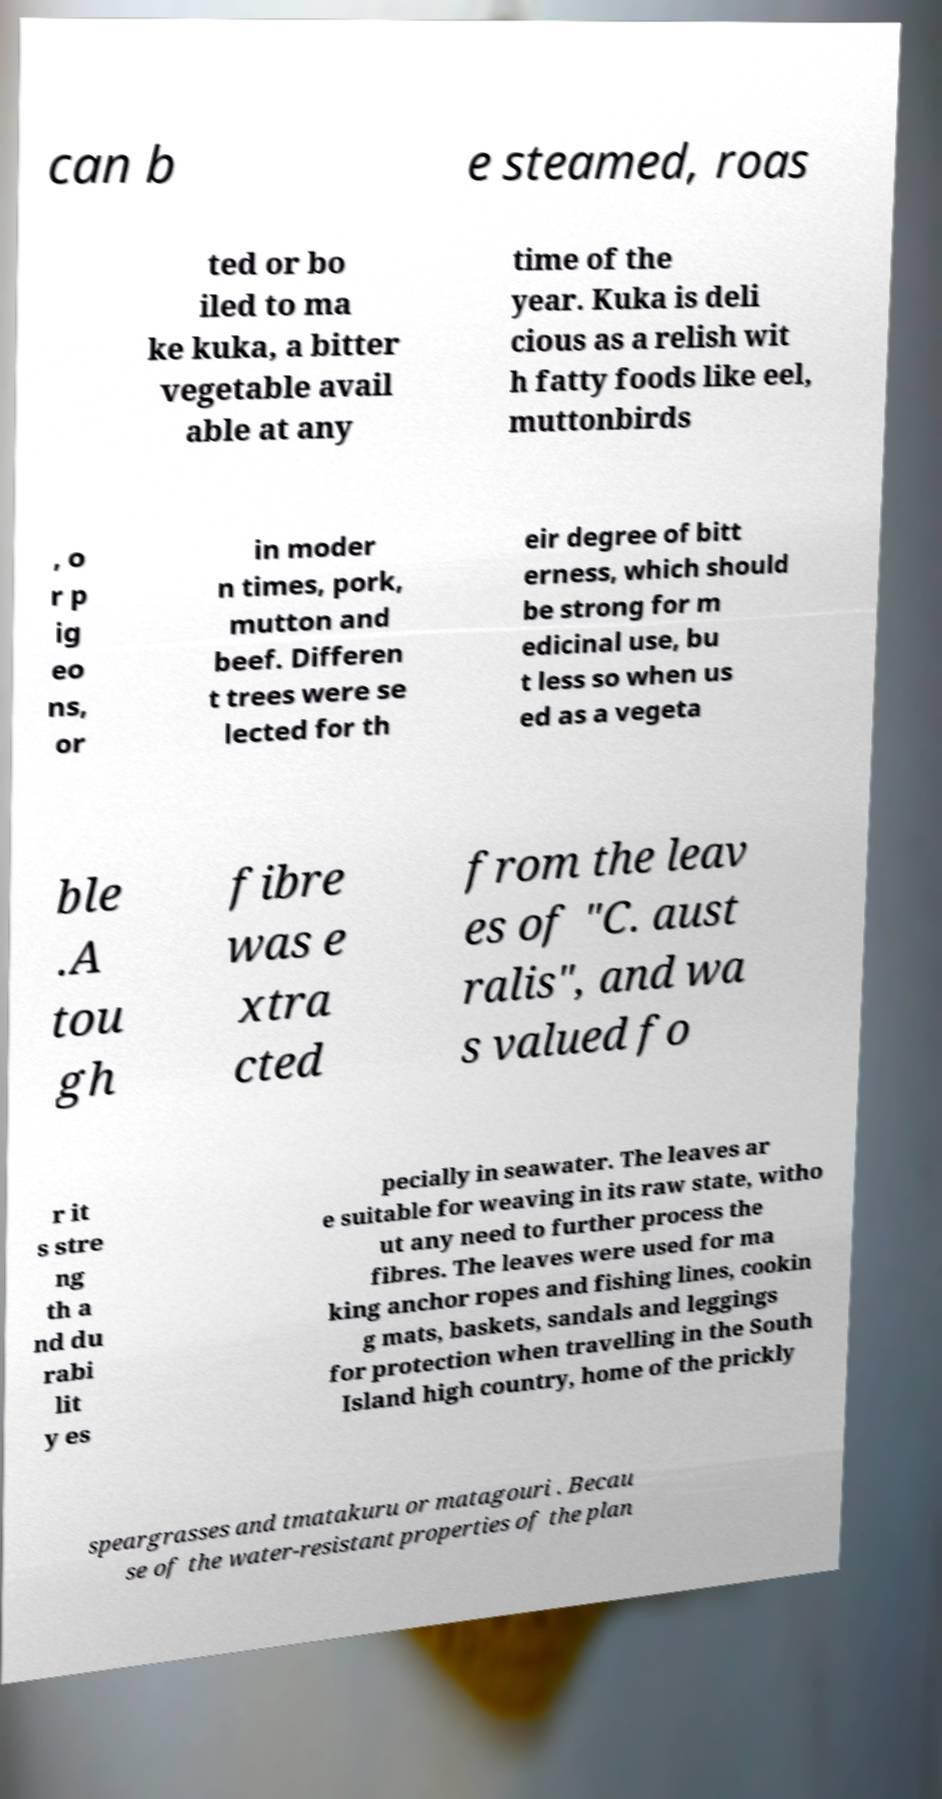Could you assist in decoding the text presented in this image and type it out clearly? can b e steamed, roas ted or bo iled to ma ke kuka, a bitter vegetable avail able at any time of the year. Kuka is deli cious as a relish wit h fatty foods like eel, muttonbirds , o r p ig eo ns, or in moder n times, pork, mutton and beef. Differen t trees were se lected for th eir degree of bitt erness, which should be strong for m edicinal use, bu t less so when us ed as a vegeta ble .A tou gh fibre was e xtra cted from the leav es of "C. aust ralis", and wa s valued fo r it s stre ng th a nd du rabi lit y es pecially in seawater. The leaves ar e suitable for weaving in its raw state, witho ut any need to further process the fibres. The leaves were used for ma king anchor ropes and fishing lines, cookin g mats, baskets, sandals and leggings for protection when travelling in the South Island high country, home of the prickly speargrasses and tmatakuru or matagouri . Becau se of the water-resistant properties of the plan 